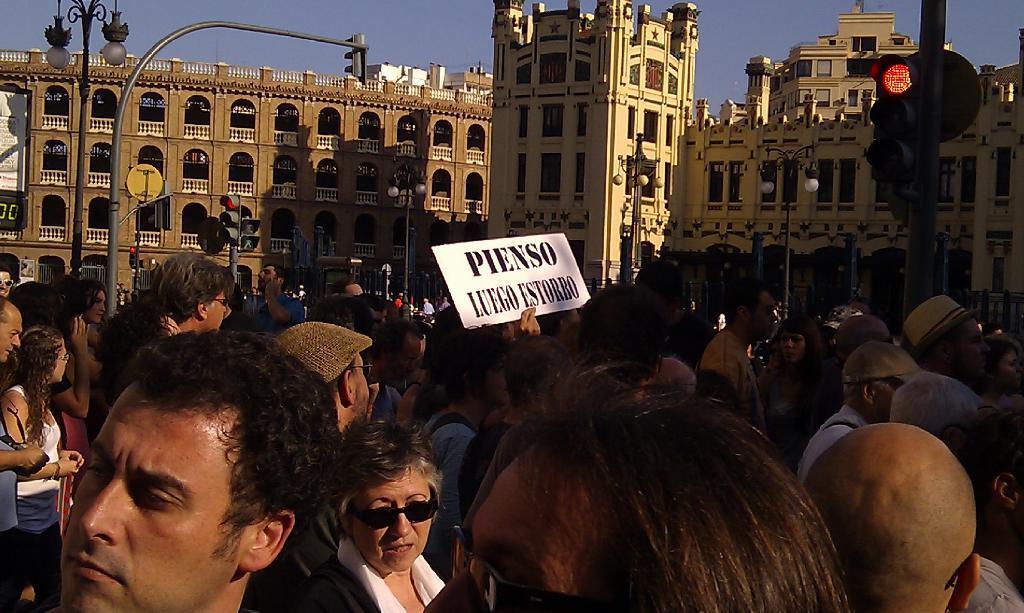How would you summarize this image in a sentence or two? In this picture we can see a group of people, one person is holding a poster, here we can see traffic signals, electric poles with lights, buildings and we can see sky in the background. 